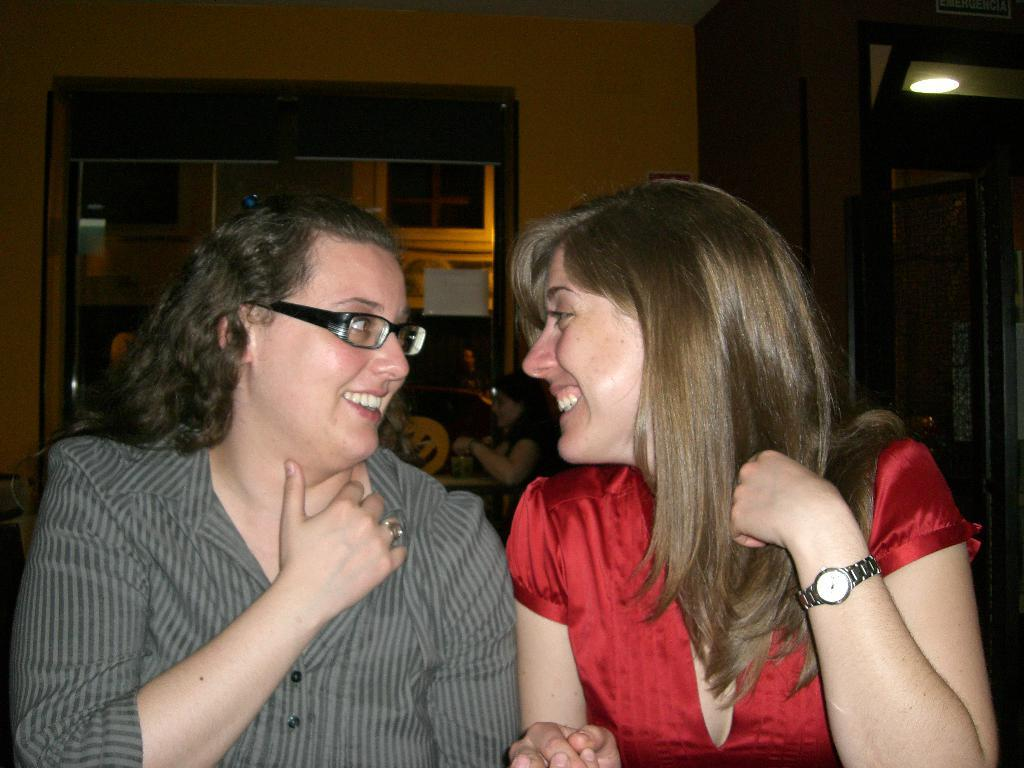How many people are in the image? There are two women in the image. What are the women doing in the image? The women are sitting on chairs. What can be seen in the background of the image? There is a wall in the background of the image. Is there any opening in the wall visible in the image? Yes, there is a window in the wall in the background of the image. What type of quartz can be seen on the floor in the image? There is no quartz present in the image; it only features two women sitting on chairs with a wall and a window in the background. 